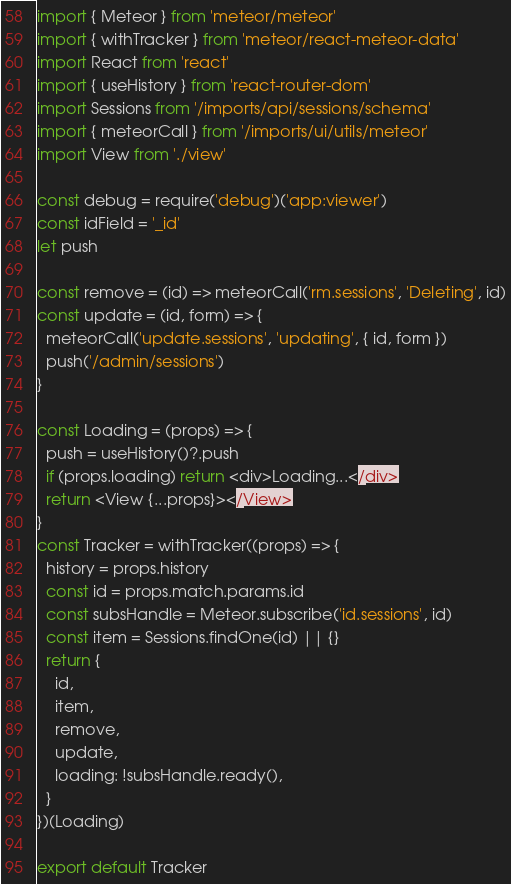Convert code to text. <code><loc_0><loc_0><loc_500><loc_500><_JavaScript_>import { Meteor } from 'meteor/meteor'
import { withTracker } from 'meteor/react-meteor-data'
import React from 'react'
import { useHistory } from 'react-router-dom'
import Sessions from '/imports/api/sessions/schema'
import { meteorCall } from '/imports/ui/utils/meteor'
import View from './view'

const debug = require('debug')('app:viewer')
const idField = '_id'
let push

const remove = (id) => meteorCall('rm.sessions', 'Deleting', id)
const update = (id, form) => {
  meteorCall('update.sessions', 'updating', { id, form })
  push('/admin/sessions')
}

const Loading = (props) => {
  push = useHistory()?.push
  if (props.loading) return <div>Loading...</div>
  return <View {...props}></View>
}
const Tracker = withTracker((props) => {
  history = props.history
  const id = props.match.params.id
  const subsHandle = Meteor.subscribe('id.sessions', id)
  const item = Sessions.findOne(id) || {}
  return {
    id,
    item,
    remove,
    update,
    loading: !subsHandle.ready(),
  }
})(Loading)

export default Tracker
</code> 